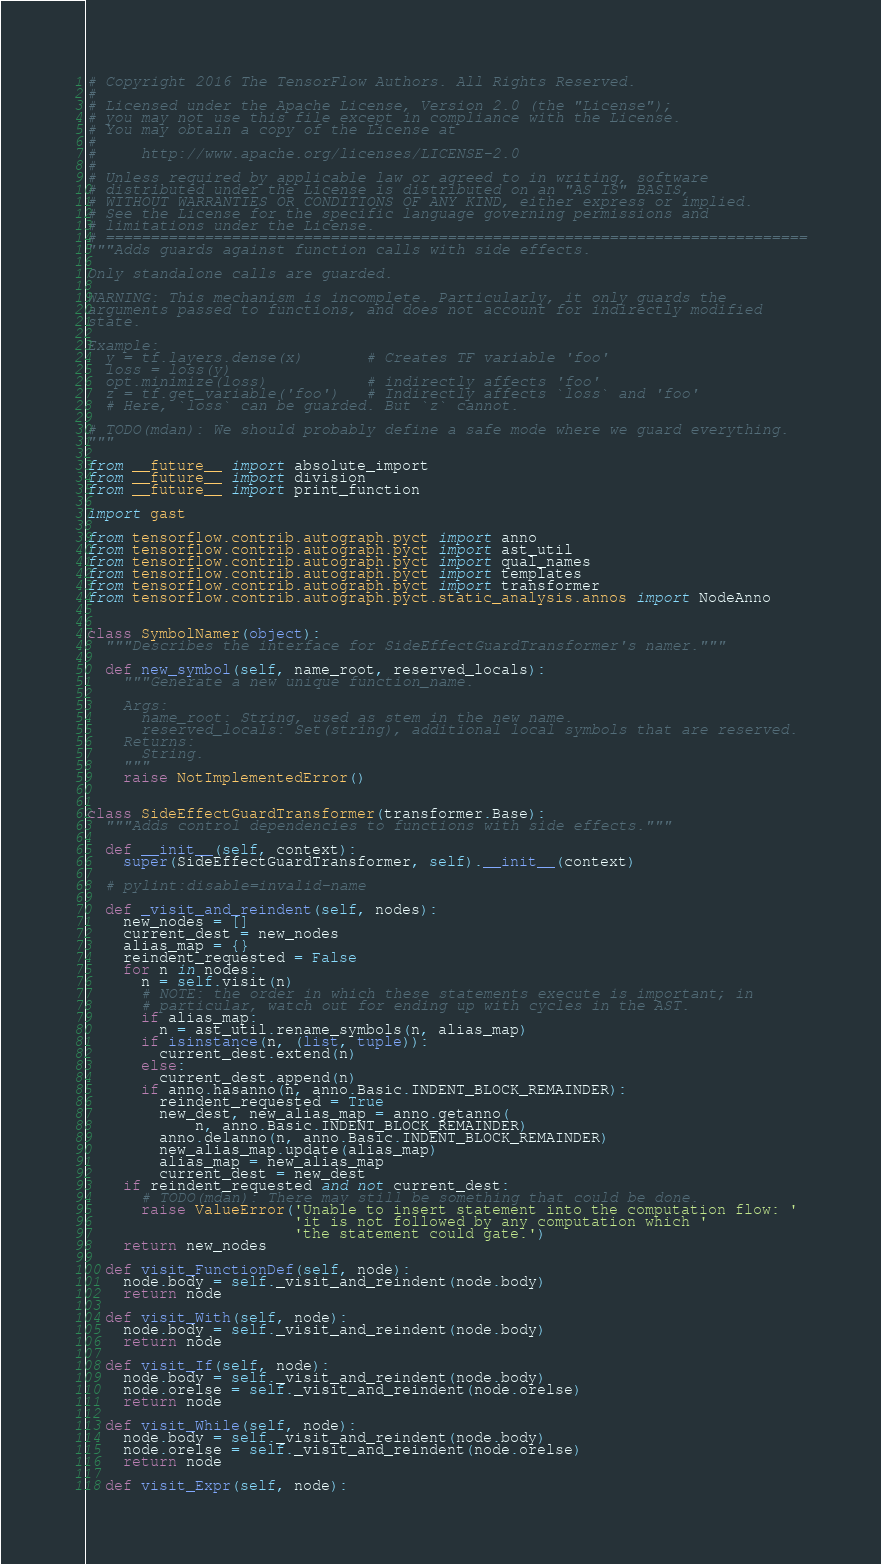Convert code to text. <code><loc_0><loc_0><loc_500><loc_500><_Python_># Copyright 2016 The TensorFlow Authors. All Rights Reserved.
#
# Licensed under the Apache License, Version 2.0 (the "License");
# you may not use this file except in compliance with the License.
# You may obtain a copy of the License at
#
#     http://www.apache.org/licenses/LICENSE-2.0
#
# Unless required by applicable law or agreed to in writing, software
# distributed under the License is distributed on an "AS IS" BASIS,
# WITHOUT WARRANTIES OR CONDITIONS OF ANY KIND, either express or implied.
# See the License for the specific language governing permissions and
# limitations under the License.
# ==============================================================================
"""Adds guards against function calls with side effects.

Only standalone calls are guarded.

WARNING: This mechanism is incomplete. Particularly, it only guards the
arguments passed to functions, and does not account for indirectly modified
state.

Example:
  y = tf.layers.dense(x)       # Creates TF variable 'foo'
  loss = loss(y)
  opt.minimize(loss)           # indirectly affects 'foo'
  z = tf.get_variable('foo')   # Indirectly affects `loss` and 'foo'
  # Here, `loss` can be guarded. But `z` cannot.

# TODO(mdan): We should probably define a safe mode where we guard everything.
"""

from __future__ import absolute_import
from __future__ import division
from __future__ import print_function

import gast

from tensorflow.contrib.autograph.pyct import anno
from tensorflow.contrib.autograph.pyct import ast_util
from tensorflow.contrib.autograph.pyct import qual_names
from tensorflow.contrib.autograph.pyct import templates
from tensorflow.contrib.autograph.pyct import transformer
from tensorflow.contrib.autograph.pyct.static_analysis.annos import NodeAnno


class SymbolNamer(object):
  """Describes the interface for SideEffectGuardTransformer's namer."""

  def new_symbol(self, name_root, reserved_locals):
    """Generate a new unique function_name.

    Args:
      name_root: String, used as stem in the new name.
      reserved_locals: Set(string), additional local symbols that are reserved.
    Returns:
      String.
    """
    raise NotImplementedError()


class SideEffectGuardTransformer(transformer.Base):
  """Adds control dependencies to functions with side effects."""

  def __init__(self, context):
    super(SideEffectGuardTransformer, self).__init__(context)

  # pylint:disable=invalid-name

  def _visit_and_reindent(self, nodes):
    new_nodes = []
    current_dest = new_nodes
    alias_map = {}
    reindent_requested = False
    for n in nodes:
      n = self.visit(n)
      # NOTE: the order in which these statements execute is important; in
      # particular, watch out for ending up with cycles in the AST.
      if alias_map:
        n = ast_util.rename_symbols(n, alias_map)
      if isinstance(n, (list, tuple)):
        current_dest.extend(n)
      else:
        current_dest.append(n)
      if anno.hasanno(n, anno.Basic.INDENT_BLOCK_REMAINDER):
        reindent_requested = True
        new_dest, new_alias_map = anno.getanno(
            n, anno.Basic.INDENT_BLOCK_REMAINDER)
        anno.delanno(n, anno.Basic.INDENT_BLOCK_REMAINDER)
        new_alias_map.update(alias_map)
        alias_map = new_alias_map
        current_dest = new_dest
    if reindent_requested and not current_dest:
      # TODO(mdan): There may still be something that could be done.
      raise ValueError('Unable to insert statement into the computation flow: '
                       'it is not followed by any computation which '
                       'the statement could gate.')
    return new_nodes

  def visit_FunctionDef(self, node):
    node.body = self._visit_and_reindent(node.body)
    return node

  def visit_With(self, node):
    node.body = self._visit_and_reindent(node.body)
    return node

  def visit_If(self, node):
    node.body = self._visit_and_reindent(node.body)
    node.orelse = self._visit_and_reindent(node.orelse)
    return node

  def visit_While(self, node):
    node.body = self._visit_and_reindent(node.body)
    node.orelse = self._visit_and_reindent(node.orelse)
    return node

  def visit_Expr(self, node):</code> 